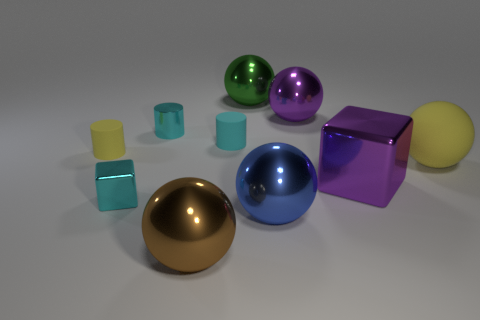Subtract all large rubber balls. How many balls are left? 4 Subtract all cyan cylinders. How many cylinders are left? 1 Subtract all cubes. How many objects are left? 8 Subtract 2 balls. How many balls are left? 3 Subtract all brown cubes. How many blue spheres are left? 1 Subtract all purple metallic cubes. Subtract all big green things. How many objects are left? 8 Add 9 matte balls. How many matte balls are left? 10 Add 1 tiny blue matte balls. How many tiny blue matte balls exist? 1 Subtract 1 yellow balls. How many objects are left? 9 Subtract all blue cubes. Subtract all red cylinders. How many cubes are left? 2 